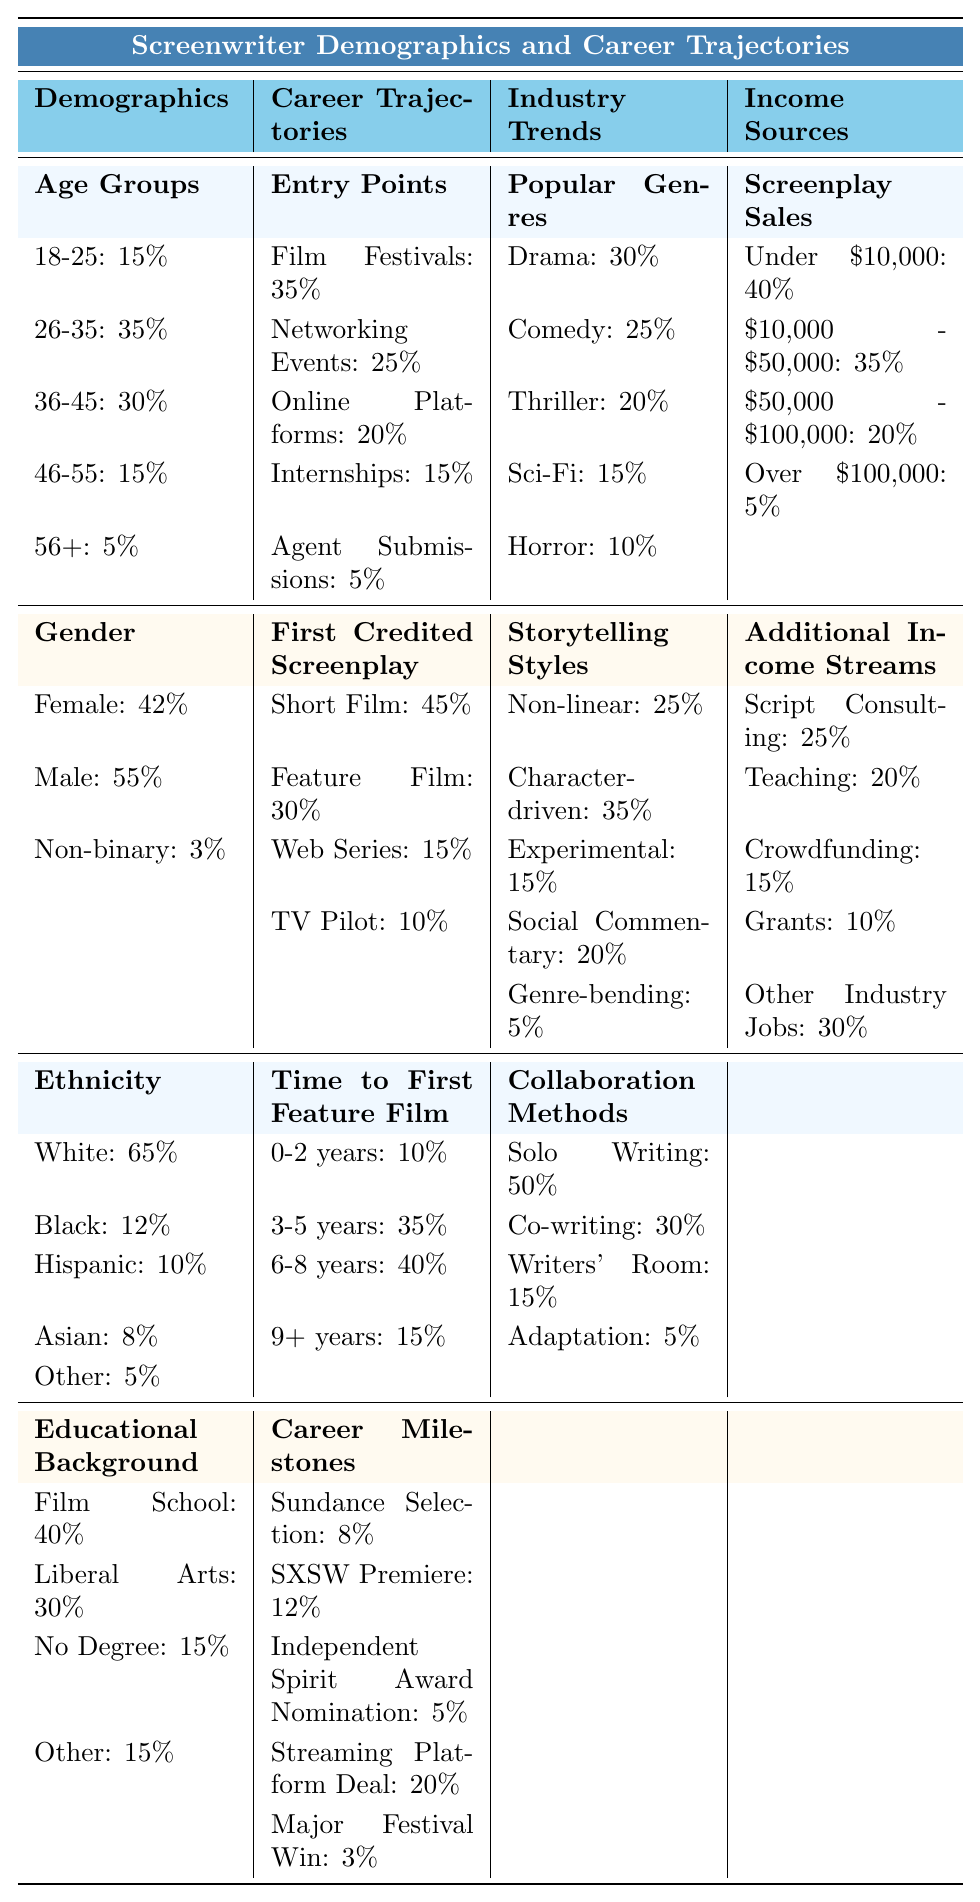What percentage of screenwriters graduated from film school? The table shows that 40% of screenwriters have a background in film school.
Answer: 40% How many screenwriters are aged 36-45? The data indicates that there are 30 screenwriters aged 36-45.
Answer: 30 What is the most common entry point for screenwriters? The highest value in the Entry Points category is Film Festivals, which accounts for 35%.
Answer: Film Festivals Are there more male or female screenwriters? The table lists 55 male screenwriters and 42 female screenwriters, indicating more males than females.
Answer: More male What percentage of screenwriters were involved in a short film as their first credited screenplay? The table states that 45% of screenwriters' first credited screenplay was a short film.
Answer: 45% How many screenwriters have a time to first feature film of 9+ years? The table shows that 15 screenwriters take 9 or more years to reach their first feature film.
Answer: 15 What is the total percentage of screenwriters who identify as either Black or Hispanic? Adding the percentages (12% for Black + 10% for Hispanic) gives a total of 22%.
Answer: 22% Among the storytelling styles, which is the most preferred by screenwriters? The highest percentage for Storytelling Styles is Character-driven, which is 35%.
Answer: Character-driven Is the majority of income for screenwriters coming from screenplay sales over $50,000? Only 5% of screenwriters earn over $100,000 from screenplay sales, while 40% earn under $10,000. Therefore, no, it is not a majority.
Answer: No What is the average time to first feature film for screenwriters who take 3-5 years and 6-8 years? To find the average, add the two percentages (35% for 3-5 years + 40% for 6-8 years = 75%), then divide by 2. The average is 75% / 2 = 37.5%.
Answer: 37.5% 